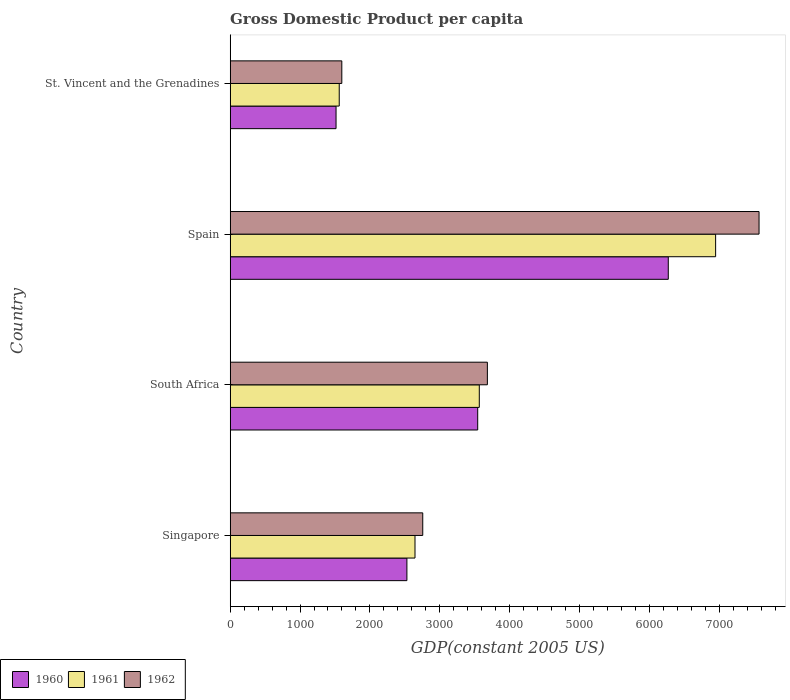How many different coloured bars are there?
Make the answer very short. 3. How many groups of bars are there?
Provide a short and direct response. 4. What is the label of the 2nd group of bars from the top?
Offer a terse response. Spain. What is the GDP per capita in 1962 in South Africa?
Provide a succinct answer. 3682.01. Across all countries, what is the maximum GDP per capita in 1960?
Provide a succinct answer. 6271.86. Across all countries, what is the minimum GDP per capita in 1960?
Make the answer very short. 1515.48. In which country was the GDP per capita in 1961 maximum?
Provide a succinct answer. Spain. In which country was the GDP per capita in 1960 minimum?
Your answer should be very brief. St. Vincent and the Grenadines. What is the total GDP per capita in 1961 in the graph?
Your answer should be compact. 1.47e+04. What is the difference between the GDP per capita in 1962 in South Africa and that in Spain?
Your answer should be very brief. -3889.23. What is the difference between the GDP per capita in 1961 in Spain and the GDP per capita in 1960 in St. Vincent and the Grenadines?
Keep it short and to the point. 5434.02. What is the average GDP per capita in 1961 per country?
Provide a succinct answer. 3680.62. What is the difference between the GDP per capita in 1962 and GDP per capita in 1960 in Singapore?
Make the answer very short. 226.9. In how many countries, is the GDP per capita in 1960 greater than 4400 US$?
Your response must be concise. 1. What is the ratio of the GDP per capita in 1962 in Singapore to that in St. Vincent and the Grenadines?
Provide a succinct answer. 1.73. Is the difference between the GDP per capita in 1962 in South Africa and St. Vincent and the Grenadines greater than the difference between the GDP per capita in 1960 in South Africa and St. Vincent and the Grenadines?
Give a very brief answer. Yes. What is the difference between the highest and the second highest GDP per capita in 1961?
Keep it short and to the point. 3383.28. What is the difference between the highest and the lowest GDP per capita in 1961?
Your response must be concise. 5388.47. How many bars are there?
Offer a terse response. 12. Are all the bars in the graph horizontal?
Offer a very short reply. Yes. How many countries are there in the graph?
Your answer should be compact. 4. Are the values on the major ticks of X-axis written in scientific E-notation?
Your answer should be compact. No. How many legend labels are there?
Your response must be concise. 3. What is the title of the graph?
Make the answer very short. Gross Domestic Product per capita. What is the label or title of the X-axis?
Ensure brevity in your answer.  GDP(constant 2005 US). What is the label or title of the Y-axis?
Ensure brevity in your answer.  Country. What is the GDP(constant 2005 US) of 1960 in Singapore?
Give a very brief answer. 2529.86. What is the GDP(constant 2005 US) of 1961 in Singapore?
Offer a very short reply. 2645.74. What is the GDP(constant 2005 US) in 1962 in Singapore?
Provide a succinct answer. 2756.76. What is the GDP(constant 2005 US) in 1960 in South Africa?
Provide a short and direct response. 3543.52. What is the GDP(constant 2005 US) in 1961 in South Africa?
Your answer should be very brief. 3566.22. What is the GDP(constant 2005 US) in 1962 in South Africa?
Keep it short and to the point. 3682.01. What is the GDP(constant 2005 US) in 1960 in Spain?
Make the answer very short. 6271.86. What is the GDP(constant 2005 US) of 1961 in Spain?
Your response must be concise. 6949.5. What is the GDP(constant 2005 US) of 1962 in Spain?
Your answer should be compact. 7571.23. What is the GDP(constant 2005 US) in 1960 in St. Vincent and the Grenadines?
Your answer should be very brief. 1515.48. What is the GDP(constant 2005 US) of 1961 in St. Vincent and the Grenadines?
Your response must be concise. 1561.03. What is the GDP(constant 2005 US) in 1962 in St. Vincent and the Grenadines?
Make the answer very short. 1598.04. Across all countries, what is the maximum GDP(constant 2005 US) in 1960?
Make the answer very short. 6271.86. Across all countries, what is the maximum GDP(constant 2005 US) in 1961?
Provide a succinct answer. 6949.5. Across all countries, what is the maximum GDP(constant 2005 US) of 1962?
Make the answer very short. 7571.23. Across all countries, what is the minimum GDP(constant 2005 US) in 1960?
Make the answer very short. 1515.48. Across all countries, what is the minimum GDP(constant 2005 US) of 1961?
Offer a terse response. 1561.03. Across all countries, what is the minimum GDP(constant 2005 US) in 1962?
Make the answer very short. 1598.04. What is the total GDP(constant 2005 US) of 1960 in the graph?
Your response must be concise. 1.39e+04. What is the total GDP(constant 2005 US) of 1961 in the graph?
Your answer should be compact. 1.47e+04. What is the total GDP(constant 2005 US) in 1962 in the graph?
Your answer should be very brief. 1.56e+04. What is the difference between the GDP(constant 2005 US) in 1960 in Singapore and that in South Africa?
Offer a very short reply. -1013.66. What is the difference between the GDP(constant 2005 US) of 1961 in Singapore and that in South Africa?
Make the answer very short. -920.48. What is the difference between the GDP(constant 2005 US) in 1962 in Singapore and that in South Africa?
Provide a succinct answer. -925.25. What is the difference between the GDP(constant 2005 US) in 1960 in Singapore and that in Spain?
Your response must be concise. -3742. What is the difference between the GDP(constant 2005 US) of 1961 in Singapore and that in Spain?
Offer a terse response. -4303.76. What is the difference between the GDP(constant 2005 US) of 1962 in Singapore and that in Spain?
Keep it short and to the point. -4814.48. What is the difference between the GDP(constant 2005 US) of 1960 in Singapore and that in St. Vincent and the Grenadines?
Your answer should be compact. 1014.38. What is the difference between the GDP(constant 2005 US) of 1961 in Singapore and that in St. Vincent and the Grenadines?
Your answer should be very brief. 1084.71. What is the difference between the GDP(constant 2005 US) in 1962 in Singapore and that in St. Vincent and the Grenadines?
Ensure brevity in your answer.  1158.72. What is the difference between the GDP(constant 2005 US) of 1960 in South Africa and that in Spain?
Give a very brief answer. -2728.34. What is the difference between the GDP(constant 2005 US) in 1961 in South Africa and that in Spain?
Your answer should be compact. -3383.28. What is the difference between the GDP(constant 2005 US) in 1962 in South Africa and that in Spain?
Offer a very short reply. -3889.23. What is the difference between the GDP(constant 2005 US) of 1960 in South Africa and that in St. Vincent and the Grenadines?
Provide a short and direct response. 2028.04. What is the difference between the GDP(constant 2005 US) of 1961 in South Africa and that in St. Vincent and the Grenadines?
Give a very brief answer. 2005.19. What is the difference between the GDP(constant 2005 US) in 1962 in South Africa and that in St. Vincent and the Grenadines?
Your answer should be compact. 2083.97. What is the difference between the GDP(constant 2005 US) of 1960 in Spain and that in St. Vincent and the Grenadines?
Give a very brief answer. 4756.38. What is the difference between the GDP(constant 2005 US) of 1961 in Spain and that in St. Vincent and the Grenadines?
Offer a very short reply. 5388.47. What is the difference between the GDP(constant 2005 US) of 1962 in Spain and that in St. Vincent and the Grenadines?
Your response must be concise. 5973.2. What is the difference between the GDP(constant 2005 US) in 1960 in Singapore and the GDP(constant 2005 US) in 1961 in South Africa?
Offer a terse response. -1036.36. What is the difference between the GDP(constant 2005 US) of 1960 in Singapore and the GDP(constant 2005 US) of 1962 in South Africa?
Offer a very short reply. -1152.15. What is the difference between the GDP(constant 2005 US) in 1961 in Singapore and the GDP(constant 2005 US) in 1962 in South Africa?
Your response must be concise. -1036.27. What is the difference between the GDP(constant 2005 US) in 1960 in Singapore and the GDP(constant 2005 US) in 1961 in Spain?
Your answer should be very brief. -4419.64. What is the difference between the GDP(constant 2005 US) of 1960 in Singapore and the GDP(constant 2005 US) of 1962 in Spain?
Your answer should be very brief. -5041.38. What is the difference between the GDP(constant 2005 US) in 1961 in Singapore and the GDP(constant 2005 US) in 1962 in Spain?
Provide a short and direct response. -4925.5. What is the difference between the GDP(constant 2005 US) in 1960 in Singapore and the GDP(constant 2005 US) in 1961 in St. Vincent and the Grenadines?
Your answer should be very brief. 968.83. What is the difference between the GDP(constant 2005 US) of 1960 in Singapore and the GDP(constant 2005 US) of 1962 in St. Vincent and the Grenadines?
Give a very brief answer. 931.82. What is the difference between the GDP(constant 2005 US) in 1961 in Singapore and the GDP(constant 2005 US) in 1962 in St. Vincent and the Grenadines?
Make the answer very short. 1047.7. What is the difference between the GDP(constant 2005 US) in 1960 in South Africa and the GDP(constant 2005 US) in 1961 in Spain?
Offer a terse response. -3405.98. What is the difference between the GDP(constant 2005 US) in 1960 in South Africa and the GDP(constant 2005 US) in 1962 in Spain?
Provide a succinct answer. -4027.71. What is the difference between the GDP(constant 2005 US) of 1961 in South Africa and the GDP(constant 2005 US) of 1962 in Spain?
Give a very brief answer. -4005.01. What is the difference between the GDP(constant 2005 US) of 1960 in South Africa and the GDP(constant 2005 US) of 1961 in St. Vincent and the Grenadines?
Make the answer very short. 1982.49. What is the difference between the GDP(constant 2005 US) in 1960 in South Africa and the GDP(constant 2005 US) in 1962 in St. Vincent and the Grenadines?
Keep it short and to the point. 1945.48. What is the difference between the GDP(constant 2005 US) of 1961 in South Africa and the GDP(constant 2005 US) of 1962 in St. Vincent and the Grenadines?
Give a very brief answer. 1968.18. What is the difference between the GDP(constant 2005 US) of 1960 in Spain and the GDP(constant 2005 US) of 1961 in St. Vincent and the Grenadines?
Give a very brief answer. 4710.83. What is the difference between the GDP(constant 2005 US) in 1960 in Spain and the GDP(constant 2005 US) in 1962 in St. Vincent and the Grenadines?
Your answer should be very brief. 4673.82. What is the difference between the GDP(constant 2005 US) of 1961 in Spain and the GDP(constant 2005 US) of 1962 in St. Vincent and the Grenadines?
Make the answer very short. 5351.46. What is the average GDP(constant 2005 US) of 1960 per country?
Give a very brief answer. 3465.18. What is the average GDP(constant 2005 US) in 1961 per country?
Provide a succinct answer. 3680.62. What is the average GDP(constant 2005 US) in 1962 per country?
Provide a short and direct response. 3902.01. What is the difference between the GDP(constant 2005 US) of 1960 and GDP(constant 2005 US) of 1961 in Singapore?
Ensure brevity in your answer.  -115.88. What is the difference between the GDP(constant 2005 US) of 1960 and GDP(constant 2005 US) of 1962 in Singapore?
Provide a short and direct response. -226.9. What is the difference between the GDP(constant 2005 US) of 1961 and GDP(constant 2005 US) of 1962 in Singapore?
Provide a succinct answer. -111.02. What is the difference between the GDP(constant 2005 US) in 1960 and GDP(constant 2005 US) in 1961 in South Africa?
Your answer should be compact. -22.7. What is the difference between the GDP(constant 2005 US) of 1960 and GDP(constant 2005 US) of 1962 in South Africa?
Provide a succinct answer. -138.49. What is the difference between the GDP(constant 2005 US) of 1961 and GDP(constant 2005 US) of 1962 in South Africa?
Ensure brevity in your answer.  -115.79. What is the difference between the GDP(constant 2005 US) in 1960 and GDP(constant 2005 US) in 1961 in Spain?
Offer a terse response. -677.64. What is the difference between the GDP(constant 2005 US) of 1960 and GDP(constant 2005 US) of 1962 in Spain?
Give a very brief answer. -1299.38. What is the difference between the GDP(constant 2005 US) in 1961 and GDP(constant 2005 US) in 1962 in Spain?
Offer a terse response. -621.73. What is the difference between the GDP(constant 2005 US) of 1960 and GDP(constant 2005 US) of 1961 in St. Vincent and the Grenadines?
Offer a terse response. -45.55. What is the difference between the GDP(constant 2005 US) of 1960 and GDP(constant 2005 US) of 1962 in St. Vincent and the Grenadines?
Provide a succinct answer. -82.55. What is the difference between the GDP(constant 2005 US) in 1961 and GDP(constant 2005 US) in 1962 in St. Vincent and the Grenadines?
Offer a very short reply. -37.01. What is the ratio of the GDP(constant 2005 US) of 1960 in Singapore to that in South Africa?
Offer a very short reply. 0.71. What is the ratio of the GDP(constant 2005 US) of 1961 in Singapore to that in South Africa?
Give a very brief answer. 0.74. What is the ratio of the GDP(constant 2005 US) of 1962 in Singapore to that in South Africa?
Your answer should be compact. 0.75. What is the ratio of the GDP(constant 2005 US) of 1960 in Singapore to that in Spain?
Give a very brief answer. 0.4. What is the ratio of the GDP(constant 2005 US) of 1961 in Singapore to that in Spain?
Ensure brevity in your answer.  0.38. What is the ratio of the GDP(constant 2005 US) of 1962 in Singapore to that in Spain?
Offer a very short reply. 0.36. What is the ratio of the GDP(constant 2005 US) in 1960 in Singapore to that in St. Vincent and the Grenadines?
Your answer should be very brief. 1.67. What is the ratio of the GDP(constant 2005 US) in 1961 in Singapore to that in St. Vincent and the Grenadines?
Offer a very short reply. 1.69. What is the ratio of the GDP(constant 2005 US) of 1962 in Singapore to that in St. Vincent and the Grenadines?
Give a very brief answer. 1.73. What is the ratio of the GDP(constant 2005 US) in 1960 in South Africa to that in Spain?
Ensure brevity in your answer.  0.56. What is the ratio of the GDP(constant 2005 US) of 1961 in South Africa to that in Spain?
Your response must be concise. 0.51. What is the ratio of the GDP(constant 2005 US) in 1962 in South Africa to that in Spain?
Offer a very short reply. 0.49. What is the ratio of the GDP(constant 2005 US) in 1960 in South Africa to that in St. Vincent and the Grenadines?
Your answer should be very brief. 2.34. What is the ratio of the GDP(constant 2005 US) in 1961 in South Africa to that in St. Vincent and the Grenadines?
Your answer should be very brief. 2.28. What is the ratio of the GDP(constant 2005 US) of 1962 in South Africa to that in St. Vincent and the Grenadines?
Make the answer very short. 2.3. What is the ratio of the GDP(constant 2005 US) in 1960 in Spain to that in St. Vincent and the Grenadines?
Give a very brief answer. 4.14. What is the ratio of the GDP(constant 2005 US) in 1961 in Spain to that in St. Vincent and the Grenadines?
Give a very brief answer. 4.45. What is the ratio of the GDP(constant 2005 US) of 1962 in Spain to that in St. Vincent and the Grenadines?
Give a very brief answer. 4.74. What is the difference between the highest and the second highest GDP(constant 2005 US) of 1960?
Keep it short and to the point. 2728.34. What is the difference between the highest and the second highest GDP(constant 2005 US) of 1961?
Offer a terse response. 3383.28. What is the difference between the highest and the second highest GDP(constant 2005 US) of 1962?
Provide a succinct answer. 3889.23. What is the difference between the highest and the lowest GDP(constant 2005 US) in 1960?
Your answer should be compact. 4756.38. What is the difference between the highest and the lowest GDP(constant 2005 US) in 1961?
Make the answer very short. 5388.47. What is the difference between the highest and the lowest GDP(constant 2005 US) of 1962?
Provide a succinct answer. 5973.2. 